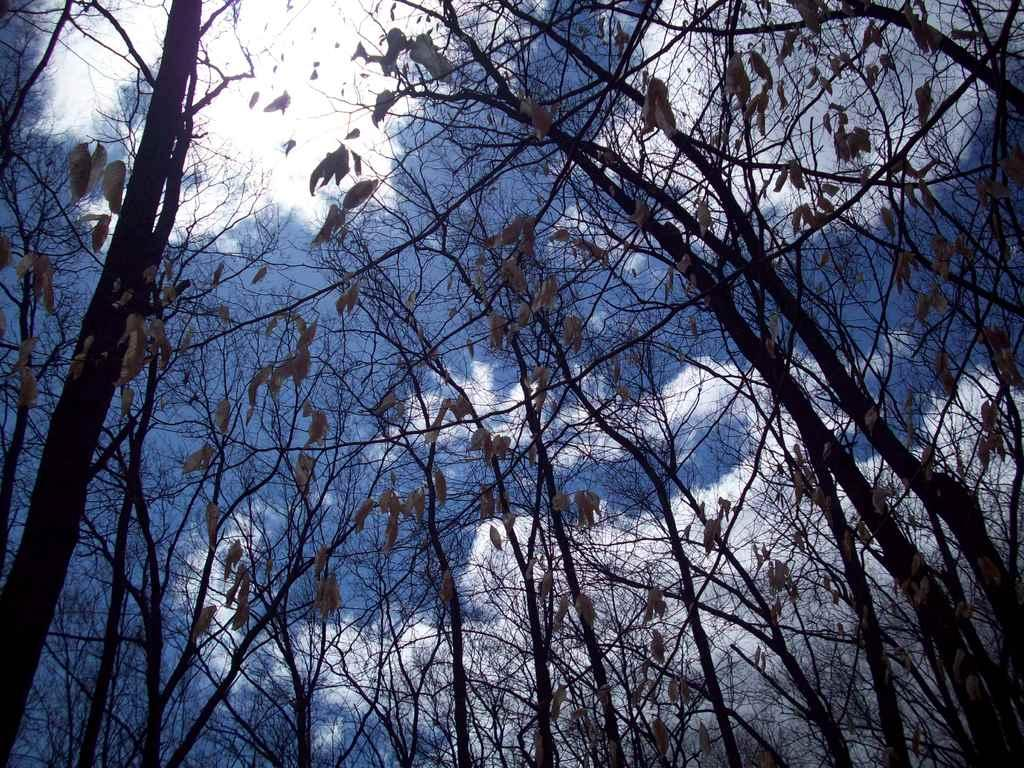What type of vegetation can be seen in the image? There is a group of trees in the image. What is visible in the background of the image? The sky is visible in the background of the image. Can you describe the sky in the image? Clouds are present in the sky. How many pins are attached to the crow in the image? There is no crow present in the image, and therefore no pins can be attached to it. What type of animal is grazing near the trees in the image? There is no animal present in the image, so it cannot be determined what type of animal might be grazing near the trees. 